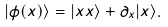Convert formula to latex. <formula><loc_0><loc_0><loc_500><loc_500>| \phi ( x ) \rangle = | x x \rangle + \partial _ { x } | x \rangle .</formula> 